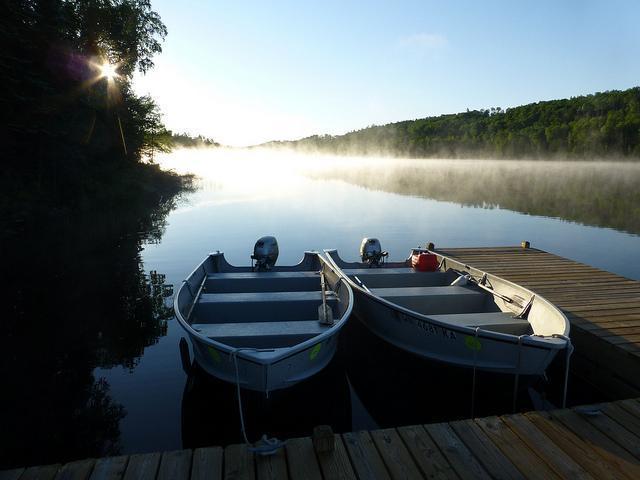How many boats are at the dock?
Give a very brief answer. 2. How many boats are in the picture?
Give a very brief answer. 2. How many boats can be seen?
Give a very brief answer. 2. How many people are wearing blue shorts?
Give a very brief answer. 0. 